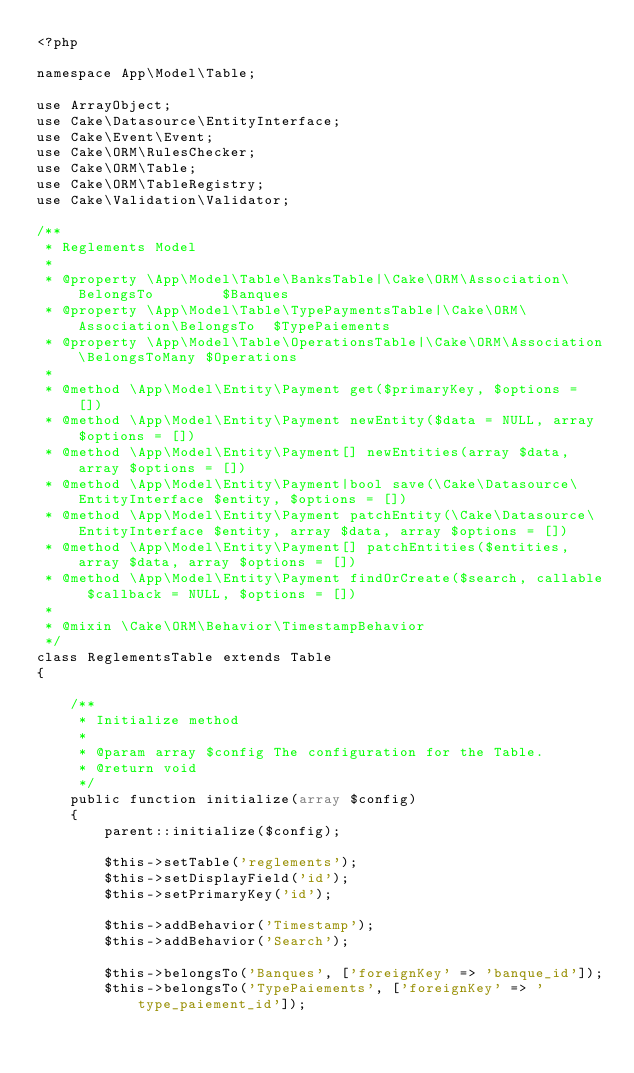Convert code to text. <code><loc_0><loc_0><loc_500><loc_500><_PHP_><?php

namespace App\Model\Table;

use ArrayObject;
use Cake\Datasource\EntityInterface;
use Cake\Event\Event;
use Cake\ORM\RulesChecker;
use Cake\ORM\Table;
use Cake\ORM\TableRegistry;
use Cake\Validation\Validator;

/**
 * Reglements Model
 *
 * @property \App\Model\Table\BanksTable|\Cake\ORM\Association\BelongsTo        $Banques
 * @property \App\Model\Table\TypePaymentsTable|\Cake\ORM\Association\BelongsTo  $TypePaiements
 * @property \App\Model\Table\OperationsTable|\Cake\ORM\Association\BelongsToMany $Operations
 *
 * @method \App\Model\Entity\Payment get($primaryKey, $options = [])
 * @method \App\Model\Entity\Payment newEntity($data = NULL, array $options = [])
 * @method \App\Model\Entity\Payment[] newEntities(array $data, array $options = [])
 * @method \App\Model\Entity\Payment|bool save(\Cake\Datasource\EntityInterface $entity, $options = [])
 * @method \App\Model\Entity\Payment patchEntity(\Cake\Datasource\EntityInterface $entity, array $data, array $options = [])
 * @method \App\Model\Entity\Payment[] patchEntities($entities, array $data, array $options = [])
 * @method \App\Model\Entity\Payment findOrCreate($search, callable $callback = NULL, $options = [])
 *
 * @mixin \Cake\ORM\Behavior\TimestampBehavior
 */
class ReglementsTable extends Table
{

    /**
     * Initialize method
     *
     * @param array $config The configuration for the Table.
     * @return void
     */
    public function initialize(array $config)
    {
        parent::initialize($config);

        $this->setTable('reglements');
        $this->setDisplayField('id');
        $this->setPrimaryKey('id');

        $this->addBehavior('Timestamp');
        $this->addBehavior('Search');

        $this->belongsTo('Banques', ['foreignKey' => 'banque_id']);
        $this->belongsTo('TypePaiements', ['foreignKey' => 'type_paiement_id']);</code> 